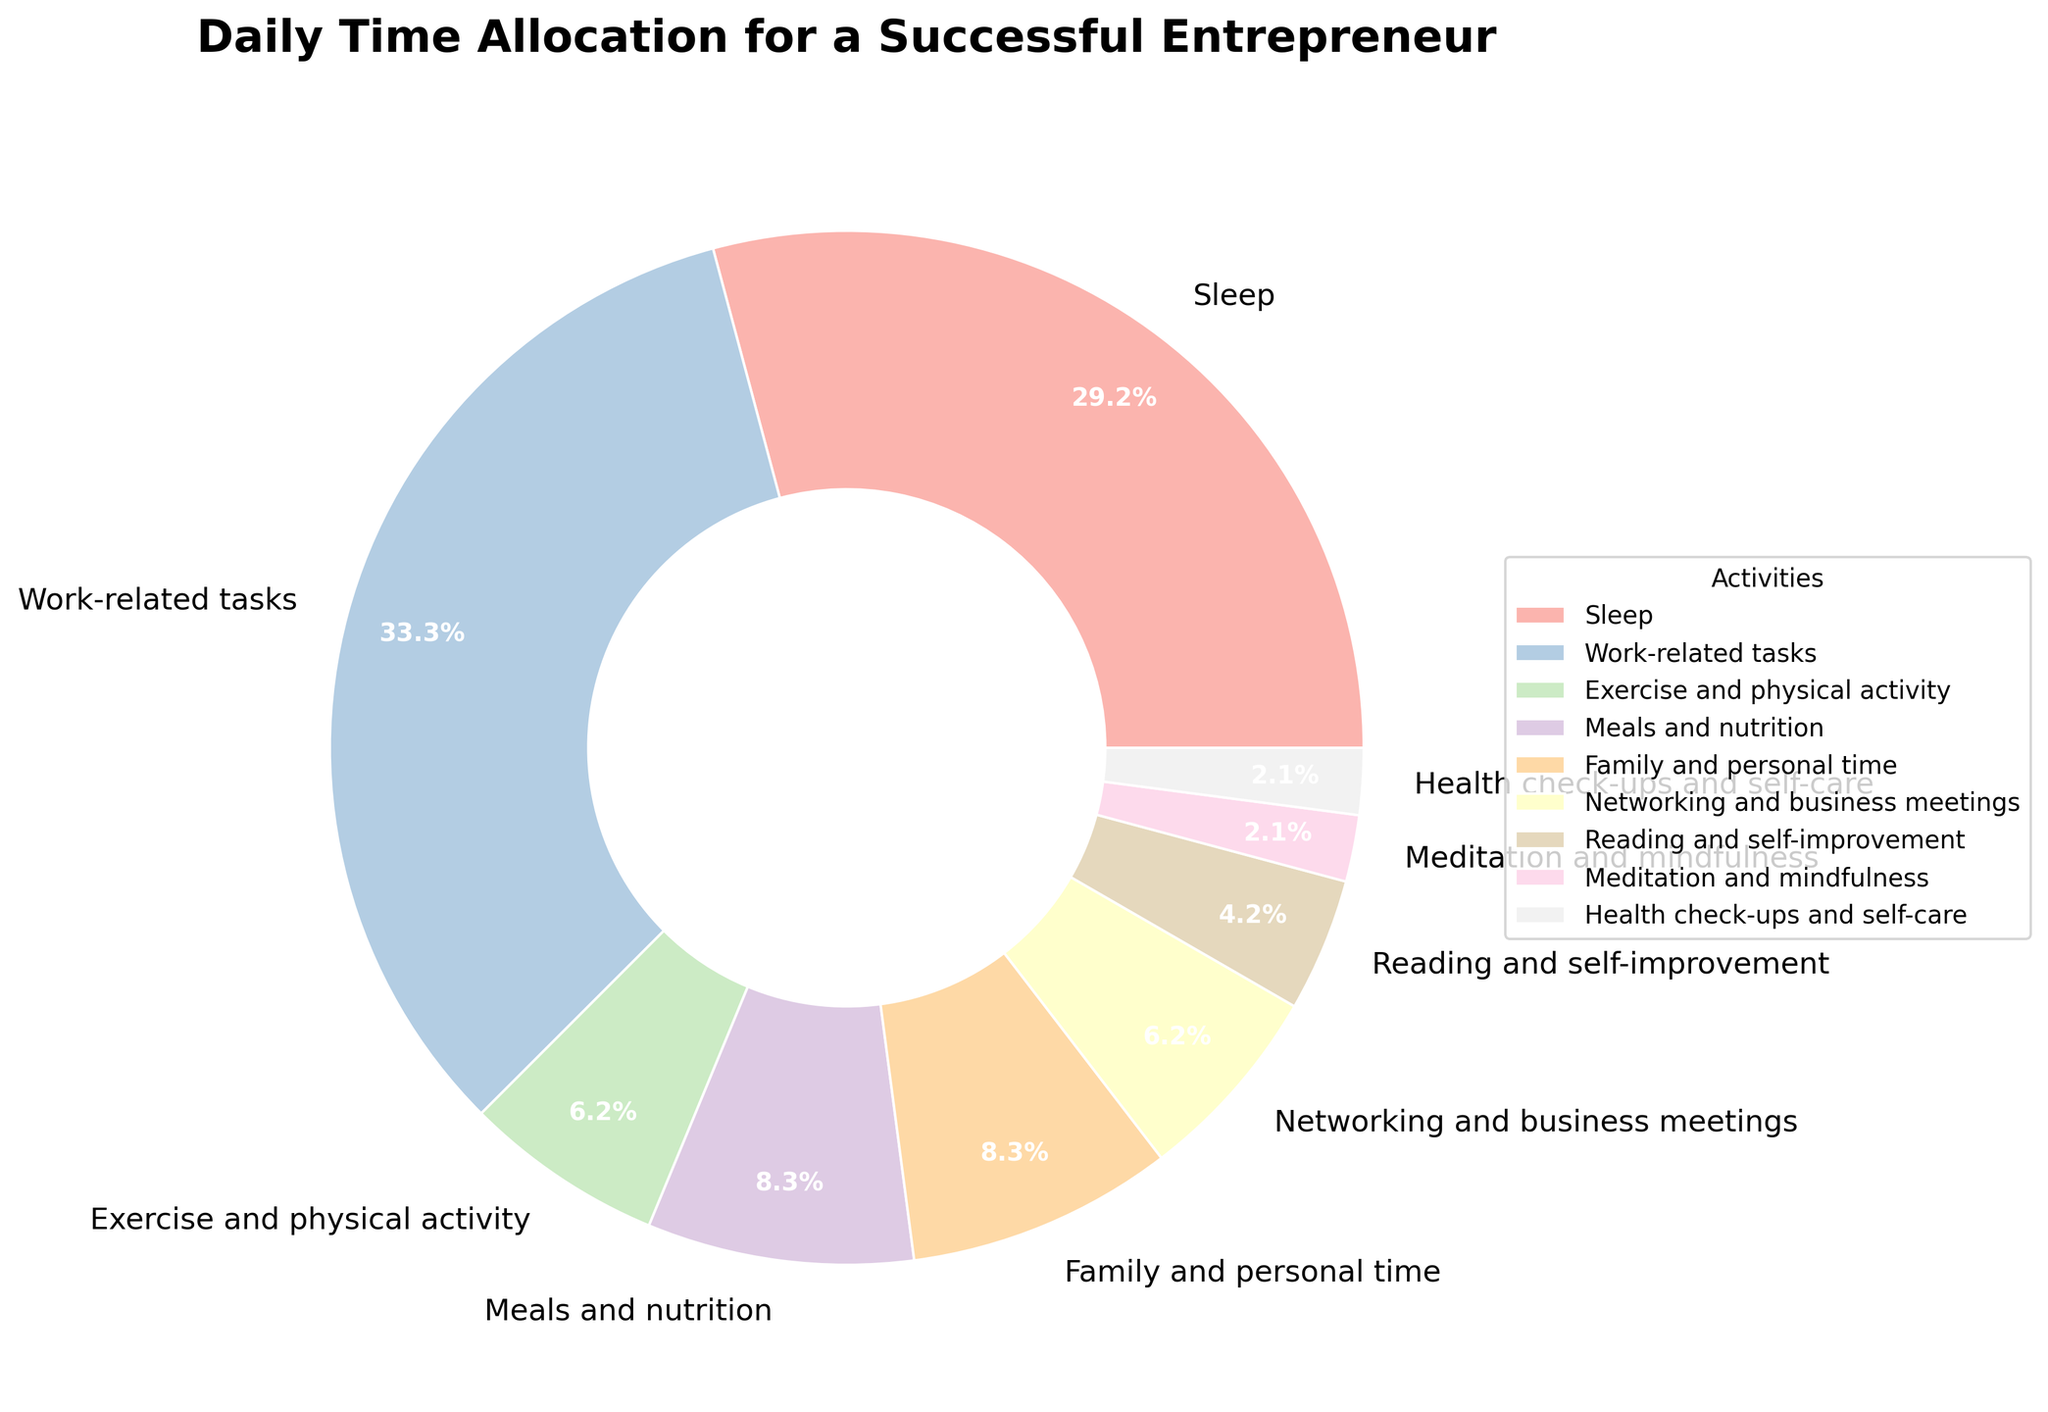What's the largest time allocation for any activity? The pie chart shows the hours allocated to each activity with percentages. The largest segment corresponds to "Sleep" which takes up 7 hours.
Answer: Sleep How many hours are dedicated to health-related activities (Exercise, Meditation, and Health check-ups combined)? Add the hours for "Exercise and physical activity" (1.5 hours), "Meditation and mindfulness" (0.5 hours), and "Health check-ups and self-care" (0.5 hours) to get the total health-related hours. So, 1.5 + 0.5 + 0.5 = 2.5 hours.
Answer: 2.5 hours Which activity consumes the least amount of time? The pie chart shows that "Meditation and mindfulness" and "Health check-ups and self-care" both take 0.5 hours, which is the smallest segment.
Answer: Meditation and mindfulness, Health check-ups and self-care Is more time spent on Networking and business meetings or Family and personal time? Compare the hours allocated to "Networking and business meetings" (1.5 hours) and "Family and personal time" (2 hours). 2 is greater than 1.5.
Answer: Family and personal time What is the percentage of the day dedicated to Meals and nutrition? The pie chart provides the percentage for each segment. Look at the segment labeled "Meals and nutrition" to find that it corresponds to 2 hours. Since there are 24 hours in a day, the percentage is (2/24)*100 = 8.3%.
Answer: 8.3% How much more time is spent sleeping compared to working out? Subtract the hours allocated for "Exercise and physical activity" (1.5 hours) from "Sleep" (7 hours) to find the difference. 7 - 1.5 = 5.5 hours.
Answer: 5.5 hours What is the total percentage of time spent on Work-related tasks and Networking combined? Combine the percentage of both activities from the pie chart. Work-related tasks have 8 hours and Networking and business meetings have 1.5 hours, so (8 + 1.5) / 24 * 100 = 39.6%.
Answer: 39.6% Which activity has a time allocation closest to the average time spent across all activities? Calculate the average by dividing total hours (24) by the number of activities (9). 24 / 9 = 2.67 hours. Compare this with the hours allocated for "Meals and nutrition" (2 hours) which is closest to 2.67 hours.
Answer: Meals and nutrition What proportion of the day is not spent on work-related tasks? The total number of hours in a day is 24. The hours spent on Work-related tasks is 8. Therefore, the remaining hours are 24 - 8 = 16 hours. The proportion is 16/24 = 2/3 or approximately 66.7%.
Answer: 66.7% 